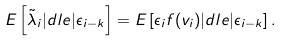<formula> <loc_0><loc_0><loc_500><loc_500>E \left [ \tilde { \lambda } _ { i } | d l e | \epsilon _ { i - k } \right ] = E \left [ \epsilon _ { i } f ( v _ { i } ) | d l e | \epsilon _ { i - k } \right ] .</formula> 